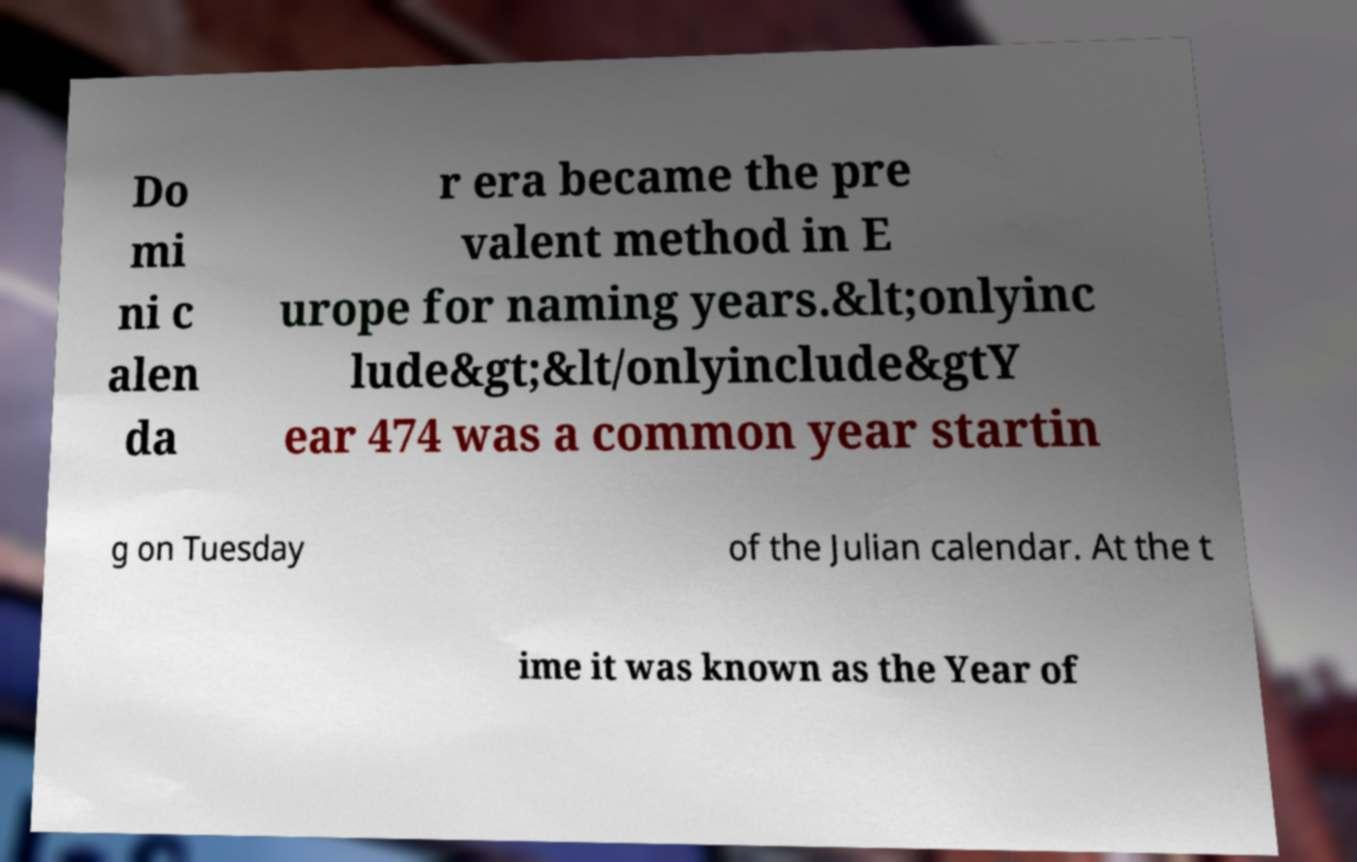Please read and relay the text visible in this image. What does it say? Do mi ni c alen da r era became the pre valent method in E urope for naming years.&lt;onlyinc lude&gt;&lt/onlyinclude&gtY ear 474 was a common year startin g on Tuesday of the Julian calendar. At the t ime it was known as the Year of 